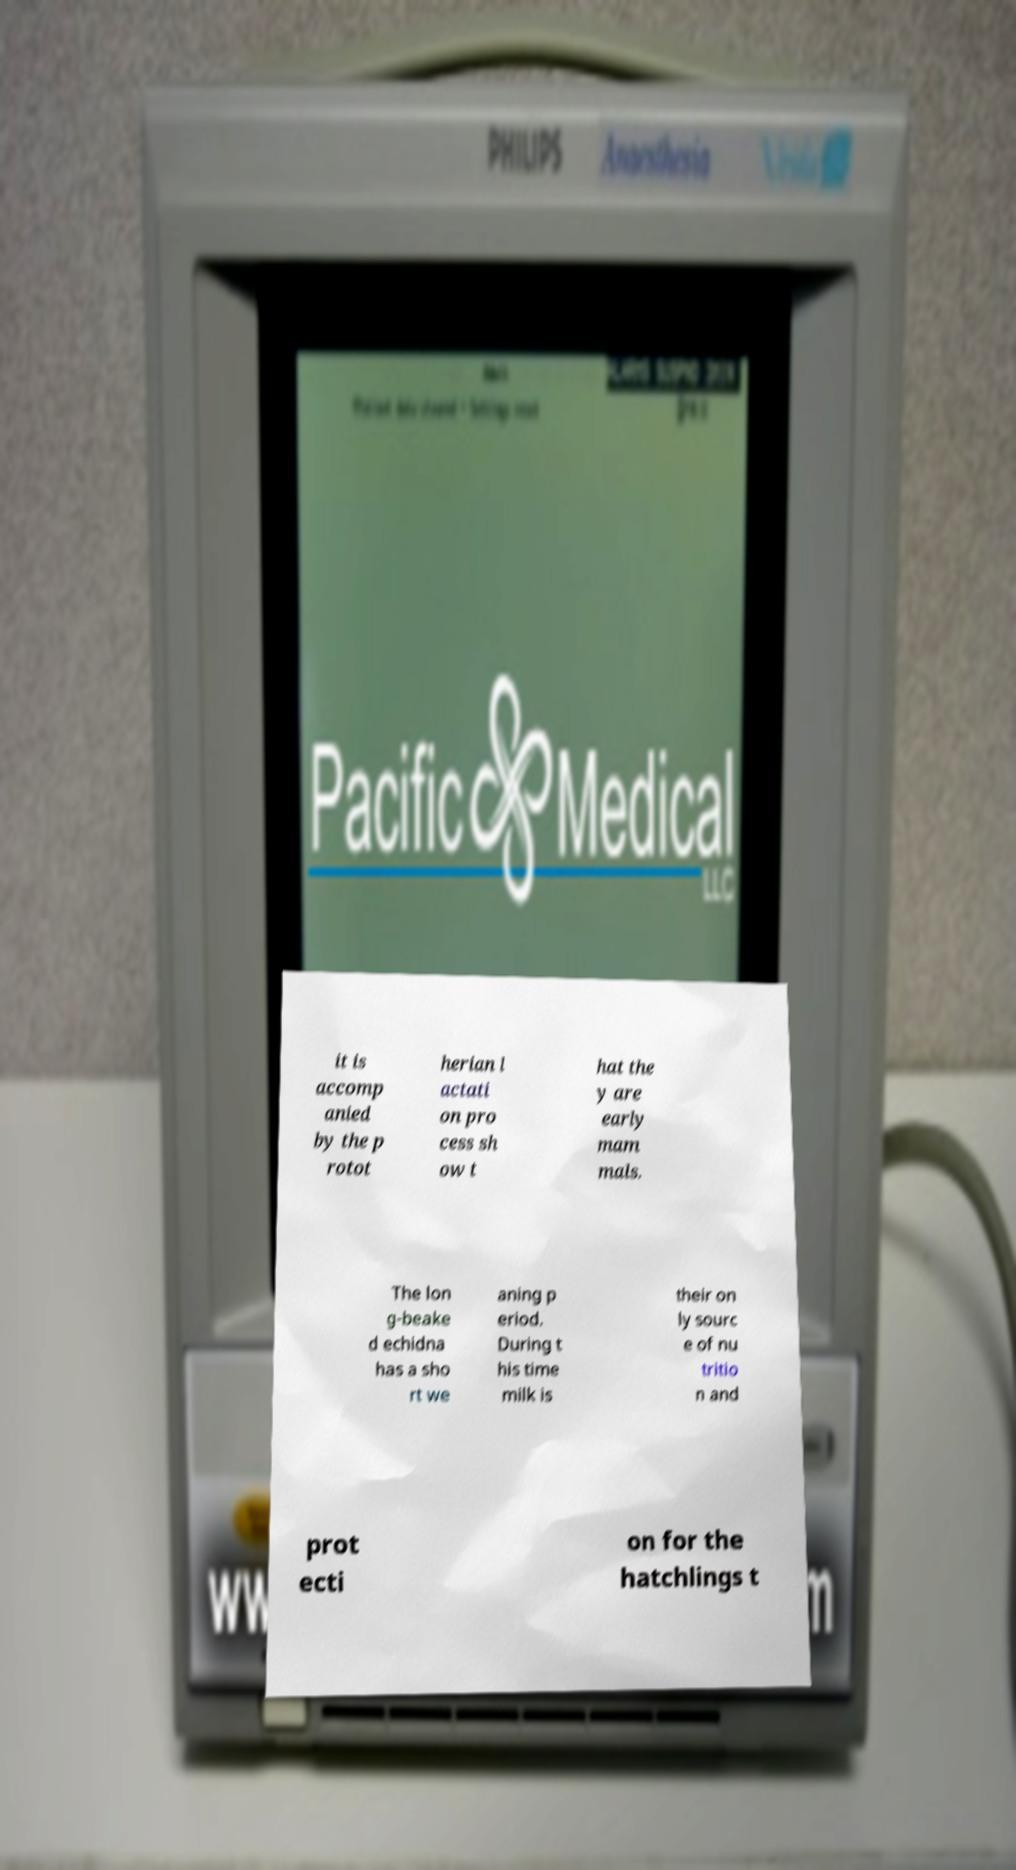What messages or text are displayed in this image? I need them in a readable, typed format. it is accomp anied by the p rotot herian l actati on pro cess sh ow t hat the y are early mam mals. The lon g-beake d echidna has a sho rt we aning p eriod. During t his time milk is their on ly sourc e of nu tritio n and prot ecti on for the hatchlings t 